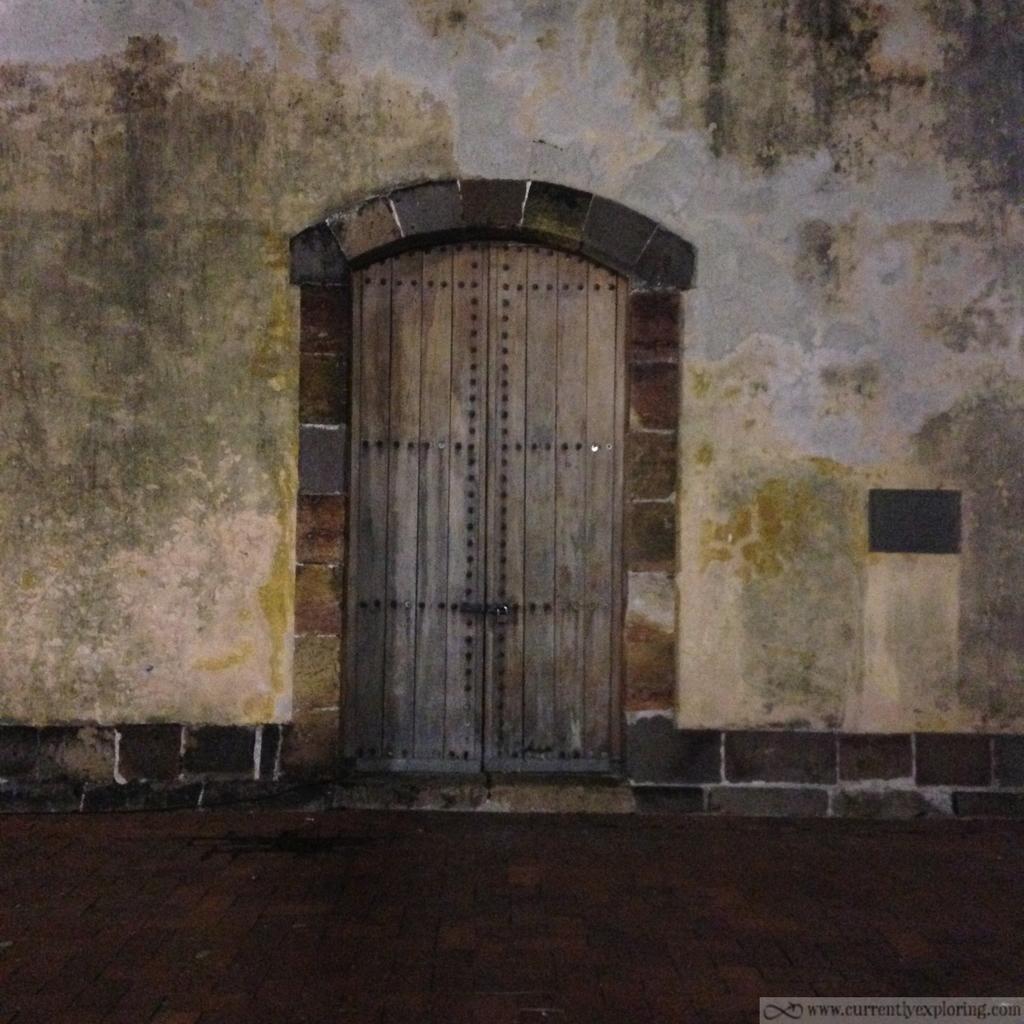Can you describe this image briefly? There is a door and wall in the center of the image and text at the bottom side. 